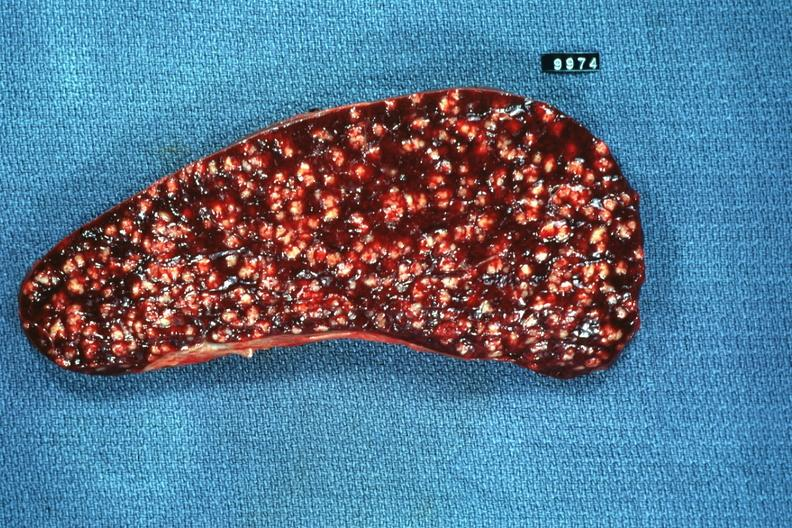s squamous cell carcinoma, lip remote, present?
Answer the question using a single word or phrase. No 